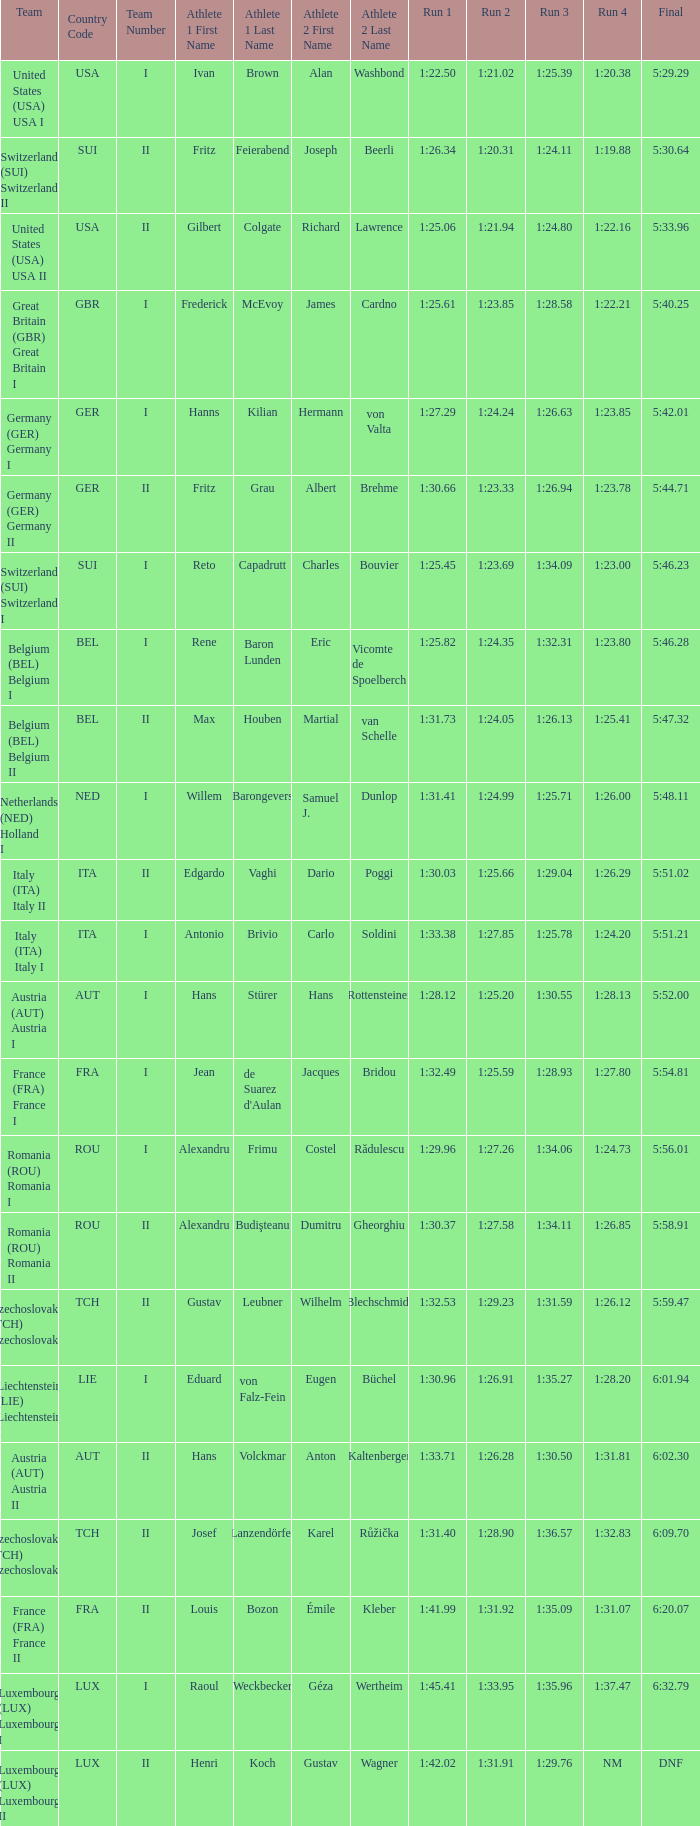Which Run 4 has a Run 1 of 1:25.82? 1:23.80. 